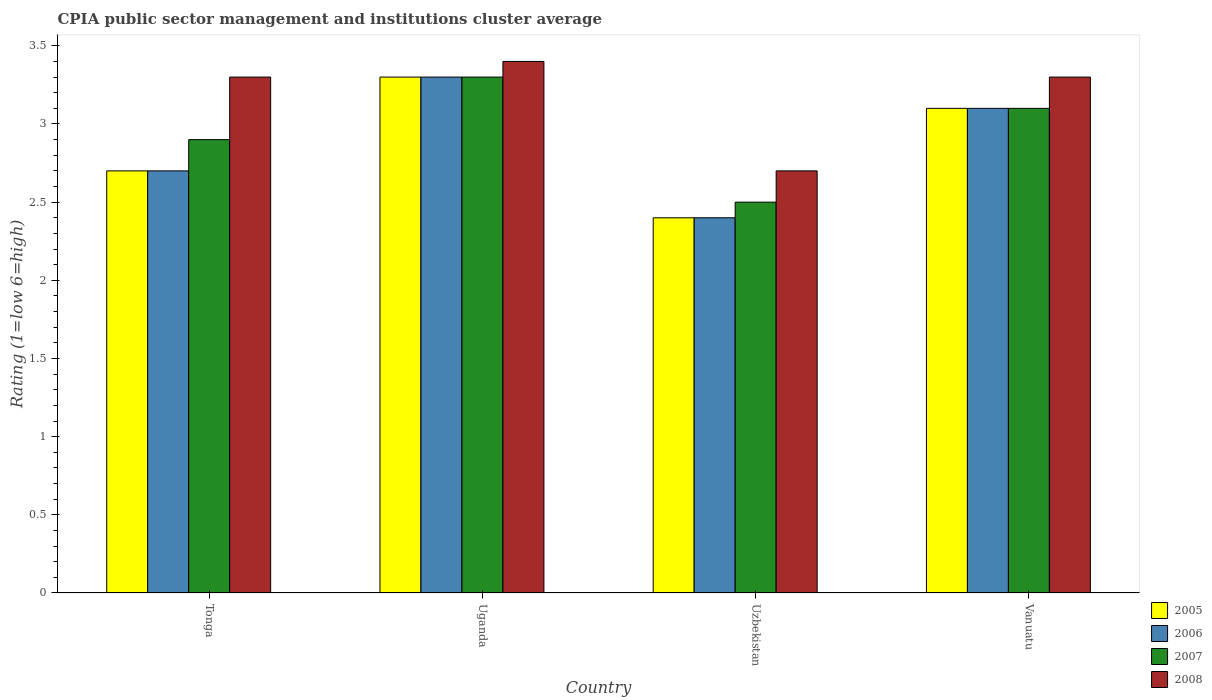How many bars are there on the 1st tick from the left?
Offer a very short reply. 4. How many bars are there on the 1st tick from the right?
Give a very brief answer. 4. What is the label of the 4th group of bars from the left?
Make the answer very short. Vanuatu. What is the CPIA rating in 2007 in Uganda?
Offer a very short reply. 3.3. Across all countries, what is the maximum CPIA rating in 2006?
Your answer should be very brief. 3.3. In which country was the CPIA rating in 2007 maximum?
Offer a very short reply. Uganda. In which country was the CPIA rating in 2007 minimum?
Give a very brief answer. Uzbekistan. What is the difference between the CPIA rating in 2005 in Tonga and that in Vanuatu?
Your answer should be very brief. -0.4. What is the difference between the CPIA rating in 2008 in Tonga and the CPIA rating in 2006 in Uzbekistan?
Your answer should be very brief. 0.9. What is the average CPIA rating in 2005 per country?
Give a very brief answer. 2.88. What is the difference between the CPIA rating of/in 2007 and CPIA rating of/in 2006 in Uzbekistan?
Offer a very short reply. 0.1. What is the ratio of the CPIA rating in 2005 in Uganda to that in Vanuatu?
Give a very brief answer. 1.06. Is the difference between the CPIA rating in 2007 in Uganda and Vanuatu greater than the difference between the CPIA rating in 2006 in Uganda and Vanuatu?
Your answer should be very brief. No. What is the difference between the highest and the second highest CPIA rating in 2005?
Your answer should be compact. 0.4. What is the difference between the highest and the lowest CPIA rating in 2007?
Offer a very short reply. 0.8. What does the 1st bar from the left in Uganda represents?
Make the answer very short. 2005. What does the 2nd bar from the right in Vanuatu represents?
Provide a short and direct response. 2007. Is it the case that in every country, the sum of the CPIA rating in 2007 and CPIA rating in 2005 is greater than the CPIA rating in 2006?
Give a very brief answer. Yes. How many bars are there?
Ensure brevity in your answer.  16. How many countries are there in the graph?
Your answer should be very brief. 4. What is the difference between two consecutive major ticks on the Y-axis?
Make the answer very short. 0.5. Does the graph contain any zero values?
Offer a very short reply. No. Where does the legend appear in the graph?
Your response must be concise. Bottom right. How many legend labels are there?
Give a very brief answer. 4. How are the legend labels stacked?
Keep it short and to the point. Vertical. What is the title of the graph?
Your answer should be compact. CPIA public sector management and institutions cluster average. Does "2009" appear as one of the legend labels in the graph?
Offer a very short reply. No. What is the label or title of the Y-axis?
Give a very brief answer. Rating (1=low 6=high). What is the Rating (1=low 6=high) of 2007 in Tonga?
Your answer should be very brief. 2.9. What is the Rating (1=low 6=high) in 2006 in Uzbekistan?
Offer a terse response. 2.4. What is the Rating (1=low 6=high) in 2005 in Vanuatu?
Your response must be concise. 3.1. What is the Rating (1=low 6=high) of 2006 in Vanuatu?
Give a very brief answer. 3.1. Across all countries, what is the maximum Rating (1=low 6=high) in 2005?
Provide a short and direct response. 3.3. Across all countries, what is the maximum Rating (1=low 6=high) of 2007?
Offer a terse response. 3.3. Across all countries, what is the maximum Rating (1=low 6=high) in 2008?
Offer a very short reply. 3.4. Across all countries, what is the minimum Rating (1=low 6=high) of 2007?
Your response must be concise. 2.5. Across all countries, what is the minimum Rating (1=low 6=high) in 2008?
Your response must be concise. 2.7. What is the total Rating (1=low 6=high) in 2006 in the graph?
Give a very brief answer. 11.5. What is the difference between the Rating (1=low 6=high) in 2007 in Tonga and that in Uganda?
Your answer should be very brief. -0.4. What is the difference between the Rating (1=low 6=high) of 2008 in Tonga and that in Uganda?
Give a very brief answer. -0.1. What is the difference between the Rating (1=low 6=high) of 2006 in Tonga and that in Uzbekistan?
Provide a succinct answer. 0.3. What is the difference between the Rating (1=low 6=high) in 2007 in Tonga and that in Vanuatu?
Your answer should be very brief. -0.2. What is the difference between the Rating (1=low 6=high) of 2008 in Tonga and that in Vanuatu?
Your answer should be compact. 0. What is the difference between the Rating (1=low 6=high) in 2005 in Uganda and that in Uzbekistan?
Your answer should be compact. 0.9. What is the difference between the Rating (1=low 6=high) in 2006 in Uganda and that in Uzbekistan?
Offer a very short reply. 0.9. What is the difference between the Rating (1=low 6=high) in 2005 in Uzbekistan and that in Vanuatu?
Make the answer very short. -0.7. What is the difference between the Rating (1=low 6=high) in 2007 in Uzbekistan and that in Vanuatu?
Ensure brevity in your answer.  -0.6. What is the difference between the Rating (1=low 6=high) in 2008 in Uzbekistan and that in Vanuatu?
Offer a very short reply. -0.6. What is the difference between the Rating (1=low 6=high) of 2005 in Tonga and the Rating (1=low 6=high) of 2007 in Uganda?
Provide a succinct answer. -0.6. What is the difference between the Rating (1=low 6=high) of 2006 in Tonga and the Rating (1=low 6=high) of 2007 in Uganda?
Your answer should be compact. -0.6. What is the difference between the Rating (1=low 6=high) of 2006 in Tonga and the Rating (1=low 6=high) of 2008 in Uganda?
Give a very brief answer. -0.7. What is the difference between the Rating (1=low 6=high) in 2007 in Tonga and the Rating (1=low 6=high) in 2008 in Uganda?
Your answer should be compact. -0.5. What is the difference between the Rating (1=low 6=high) of 2005 in Tonga and the Rating (1=low 6=high) of 2007 in Uzbekistan?
Your answer should be very brief. 0.2. What is the difference between the Rating (1=low 6=high) of 2005 in Tonga and the Rating (1=low 6=high) of 2008 in Uzbekistan?
Your response must be concise. 0. What is the difference between the Rating (1=low 6=high) of 2006 in Tonga and the Rating (1=low 6=high) of 2007 in Uzbekistan?
Your answer should be very brief. 0.2. What is the difference between the Rating (1=low 6=high) of 2005 in Tonga and the Rating (1=low 6=high) of 2007 in Vanuatu?
Your answer should be compact. -0.4. What is the difference between the Rating (1=low 6=high) in 2005 in Uganda and the Rating (1=low 6=high) in 2006 in Uzbekistan?
Offer a terse response. 0.9. What is the difference between the Rating (1=low 6=high) of 2007 in Uganda and the Rating (1=low 6=high) of 2008 in Uzbekistan?
Keep it short and to the point. 0.6. What is the difference between the Rating (1=low 6=high) in 2005 in Uganda and the Rating (1=low 6=high) in 2007 in Vanuatu?
Your answer should be very brief. 0.2. What is the difference between the Rating (1=low 6=high) in 2005 in Uganda and the Rating (1=low 6=high) in 2008 in Vanuatu?
Make the answer very short. 0. What is the difference between the Rating (1=low 6=high) of 2006 in Uganda and the Rating (1=low 6=high) of 2007 in Vanuatu?
Provide a short and direct response. 0.2. What is the difference between the Rating (1=low 6=high) in 2006 in Uganda and the Rating (1=low 6=high) in 2008 in Vanuatu?
Your response must be concise. 0. What is the difference between the Rating (1=low 6=high) in 2005 in Uzbekistan and the Rating (1=low 6=high) in 2007 in Vanuatu?
Your answer should be compact. -0.7. What is the difference between the Rating (1=low 6=high) of 2006 in Uzbekistan and the Rating (1=low 6=high) of 2008 in Vanuatu?
Ensure brevity in your answer.  -0.9. What is the average Rating (1=low 6=high) in 2005 per country?
Make the answer very short. 2.88. What is the average Rating (1=low 6=high) of 2006 per country?
Your answer should be very brief. 2.88. What is the average Rating (1=low 6=high) of 2007 per country?
Your response must be concise. 2.95. What is the average Rating (1=low 6=high) in 2008 per country?
Offer a terse response. 3.17. What is the difference between the Rating (1=low 6=high) in 2005 and Rating (1=low 6=high) in 2006 in Tonga?
Make the answer very short. 0. What is the difference between the Rating (1=low 6=high) of 2005 and Rating (1=low 6=high) of 2007 in Tonga?
Keep it short and to the point. -0.2. What is the difference between the Rating (1=low 6=high) of 2005 and Rating (1=low 6=high) of 2008 in Tonga?
Give a very brief answer. -0.6. What is the difference between the Rating (1=low 6=high) in 2006 and Rating (1=low 6=high) in 2007 in Tonga?
Offer a terse response. -0.2. What is the difference between the Rating (1=low 6=high) in 2005 and Rating (1=low 6=high) in 2006 in Uganda?
Provide a short and direct response. 0. What is the difference between the Rating (1=low 6=high) of 2006 and Rating (1=low 6=high) of 2007 in Uganda?
Provide a short and direct response. 0. What is the difference between the Rating (1=low 6=high) in 2007 and Rating (1=low 6=high) in 2008 in Uganda?
Your answer should be compact. -0.1. What is the difference between the Rating (1=low 6=high) of 2005 and Rating (1=low 6=high) of 2006 in Uzbekistan?
Provide a succinct answer. 0. What is the difference between the Rating (1=low 6=high) of 2006 and Rating (1=low 6=high) of 2008 in Uzbekistan?
Make the answer very short. -0.3. What is the difference between the Rating (1=low 6=high) in 2007 and Rating (1=low 6=high) in 2008 in Uzbekistan?
Your answer should be very brief. -0.2. What is the difference between the Rating (1=low 6=high) of 2005 and Rating (1=low 6=high) of 2006 in Vanuatu?
Keep it short and to the point. 0. What is the difference between the Rating (1=low 6=high) of 2005 and Rating (1=low 6=high) of 2008 in Vanuatu?
Provide a short and direct response. -0.2. What is the difference between the Rating (1=low 6=high) of 2006 and Rating (1=low 6=high) of 2007 in Vanuatu?
Your answer should be very brief. 0. What is the difference between the Rating (1=low 6=high) in 2006 and Rating (1=low 6=high) in 2008 in Vanuatu?
Provide a short and direct response. -0.2. What is the difference between the Rating (1=low 6=high) in 2007 and Rating (1=low 6=high) in 2008 in Vanuatu?
Ensure brevity in your answer.  -0.2. What is the ratio of the Rating (1=low 6=high) of 2005 in Tonga to that in Uganda?
Ensure brevity in your answer.  0.82. What is the ratio of the Rating (1=low 6=high) in 2006 in Tonga to that in Uganda?
Give a very brief answer. 0.82. What is the ratio of the Rating (1=low 6=high) of 2007 in Tonga to that in Uganda?
Keep it short and to the point. 0.88. What is the ratio of the Rating (1=low 6=high) in 2008 in Tonga to that in Uganda?
Offer a very short reply. 0.97. What is the ratio of the Rating (1=low 6=high) in 2005 in Tonga to that in Uzbekistan?
Make the answer very short. 1.12. What is the ratio of the Rating (1=low 6=high) in 2007 in Tonga to that in Uzbekistan?
Ensure brevity in your answer.  1.16. What is the ratio of the Rating (1=low 6=high) in 2008 in Tonga to that in Uzbekistan?
Your response must be concise. 1.22. What is the ratio of the Rating (1=low 6=high) in 2005 in Tonga to that in Vanuatu?
Keep it short and to the point. 0.87. What is the ratio of the Rating (1=low 6=high) in 2006 in Tonga to that in Vanuatu?
Ensure brevity in your answer.  0.87. What is the ratio of the Rating (1=low 6=high) in 2007 in Tonga to that in Vanuatu?
Make the answer very short. 0.94. What is the ratio of the Rating (1=low 6=high) of 2005 in Uganda to that in Uzbekistan?
Your answer should be very brief. 1.38. What is the ratio of the Rating (1=low 6=high) in 2006 in Uganda to that in Uzbekistan?
Make the answer very short. 1.38. What is the ratio of the Rating (1=low 6=high) of 2007 in Uganda to that in Uzbekistan?
Your response must be concise. 1.32. What is the ratio of the Rating (1=low 6=high) of 2008 in Uganda to that in Uzbekistan?
Your answer should be compact. 1.26. What is the ratio of the Rating (1=low 6=high) in 2005 in Uganda to that in Vanuatu?
Provide a short and direct response. 1.06. What is the ratio of the Rating (1=low 6=high) in 2006 in Uganda to that in Vanuatu?
Your answer should be compact. 1.06. What is the ratio of the Rating (1=low 6=high) in 2007 in Uganda to that in Vanuatu?
Give a very brief answer. 1.06. What is the ratio of the Rating (1=low 6=high) of 2008 in Uganda to that in Vanuatu?
Ensure brevity in your answer.  1.03. What is the ratio of the Rating (1=low 6=high) of 2005 in Uzbekistan to that in Vanuatu?
Give a very brief answer. 0.77. What is the ratio of the Rating (1=low 6=high) of 2006 in Uzbekistan to that in Vanuatu?
Provide a short and direct response. 0.77. What is the ratio of the Rating (1=low 6=high) of 2007 in Uzbekistan to that in Vanuatu?
Provide a succinct answer. 0.81. What is the ratio of the Rating (1=low 6=high) of 2008 in Uzbekistan to that in Vanuatu?
Give a very brief answer. 0.82. What is the difference between the highest and the second highest Rating (1=low 6=high) in 2005?
Offer a terse response. 0.2. What is the difference between the highest and the second highest Rating (1=low 6=high) of 2006?
Provide a short and direct response. 0.2. What is the difference between the highest and the second highest Rating (1=low 6=high) of 2007?
Give a very brief answer. 0.2. 